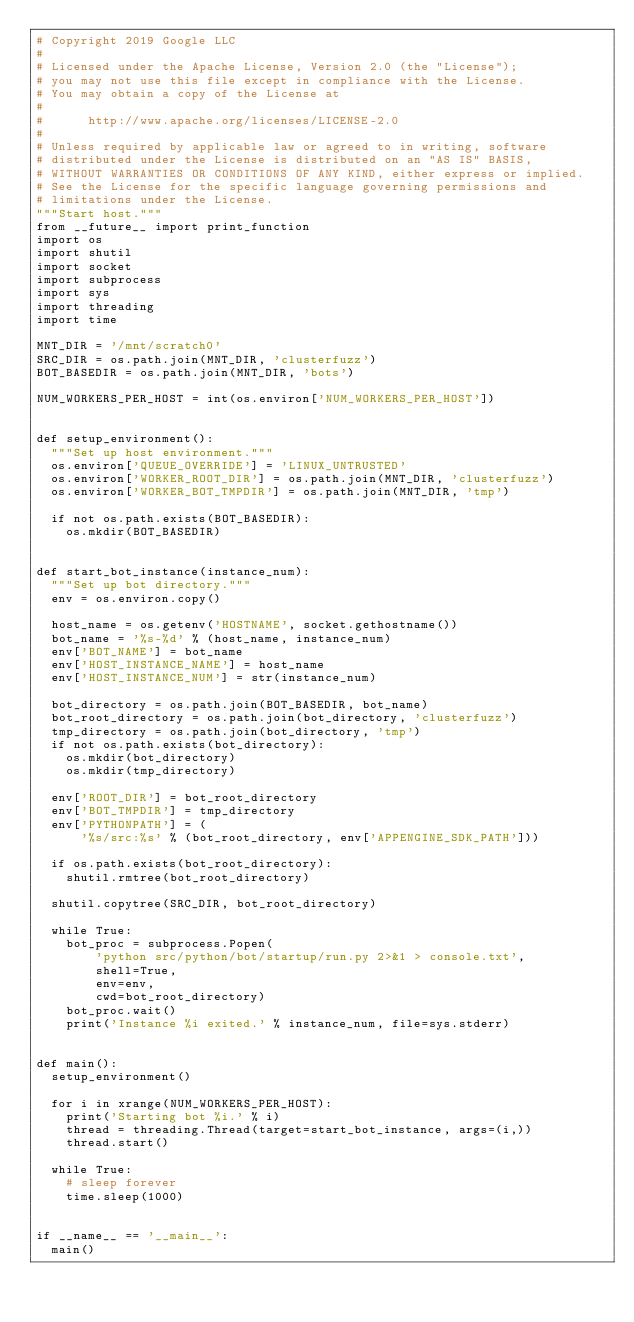<code> <loc_0><loc_0><loc_500><loc_500><_Python_># Copyright 2019 Google LLC
#
# Licensed under the Apache License, Version 2.0 (the "License");
# you may not use this file except in compliance with the License.
# You may obtain a copy of the License at
#
#      http://www.apache.org/licenses/LICENSE-2.0
#
# Unless required by applicable law or agreed to in writing, software
# distributed under the License is distributed on an "AS IS" BASIS,
# WITHOUT WARRANTIES OR CONDITIONS OF ANY KIND, either express or implied.
# See the License for the specific language governing permissions and
# limitations under the License.
"""Start host."""
from __future__ import print_function
import os
import shutil
import socket
import subprocess
import sys
import threading
import time

MNT_DIR = '/mnt/scratch0'
SRC_DIR = os.path.join(MNT_DIR, 'clusterfuzz')
BOT_BASEDIR = os.path.join(MNT_DIR, 'bots')

NUM_WORKERS_PER_HOST = int(os.environ['NUM_WORKERS_PER_HOST'])


def setup_environment():
  """Set up host environment."""
  os.environ['QUEUE_OVERRIDE'] = 'LINUX_UNTRUSTED'
  os.environ['WORKER_ROOT_DIR'] = os.path.join(MNT_DIR, 'clusterfuzz')
  os.environ['WORKER_BOT_TMPDIR'] = os.path.join(MNT_DIR, 'tmp')

  if not os.path.exists(BOT_BASEDIR):
    os.mkdir(BOT_BASEDIR)


def start_bot_instance(instance_num):
  """Set up bot directory."""
  env = os.environ.copy()

  host_name = os.getenv('HOSTNAME', socket.gethostname())
  bot_name = '%s-%d' % (host_name, instance_num)
  env['BOT_NAME'] = bot_name
  env['HOST_INSTANCE_NAME'] = host_name
  env['HOST_INSTANCE_NUM'] = str(instance_num)

  bot_directory = os.path.join(BOT_BASEDIR, bot_name)
  bot_root_directory = os.path.join(bot_directory, 'clusterfuzz')
  tmp_directory = os.path.join(bot_directory, 'tmp')
  if not os.path.exists(bot_directory):
    os.mkdir(bot_directory)
    os.mkdir(tmp_directory)

  env['ROOT_DIR'] = bot_root_directory
  env['BOT_TMPDIR'] = tmp_directory
  env['PYTHONPATH'] = (
      '%s/src:%s' % (bot_root_directory, env['APPENGINE_SDK_PATH']))

  if os.path.exists(bot_root_directory):
    shutil.rmtree(bot_root_directory)

  shutil.copytree(SRC_DIR, bot_root_directory)

  while True:
    bot_proc = subprocess.Popen(
        'python src/python/bot/startup/run.py 2>&1 > console.txt',
        shell=True,
        env=env,
        cwd=bot_root_directory)
    bot_proc.wait()
    print('Instance %i exited.' % instance_num, file=sys.stderr)


def main():
  setup_environment()

  for i in xrange(NUM_WORKERS_PER_HOST):
    print('Starting bot %i.' % i)
    thread = threading.Thread(target=start_bot_instance, args=(i,))
    thread.start()

  while True:
    # sleep forever
    time.sleep(1000)


if __name__ == '__main__':
  main()
</code> 